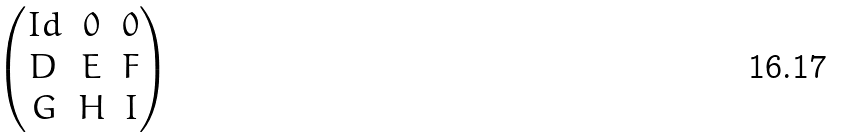<formula> <loc_0><loc_0><loc_500><loc_500>\begin{pmatrix} I d & 0 & 0 \\ D & E & F \\ G & H & I \end{pmatrix}</formula> 